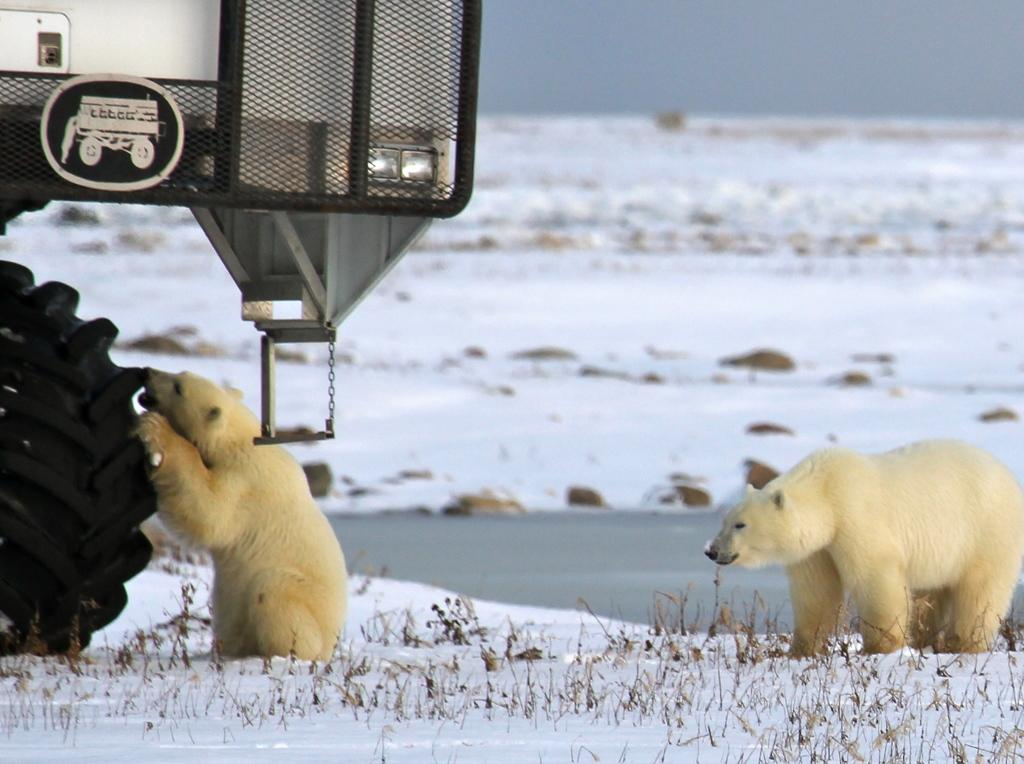What is the main subject in the center of the image? There is a vehicle in the center of the image. What animals are present in the image? There are two polar bears in the image. What color are the polar bears? The polar bears are cream-colored. What can be seen in the background of the image? There is sky, snow, water, and grass visible in the background of the image. What letters are the polar bears spelling out in the image? There are no letters present in the image, and the polar bears are not spelling out any words. 